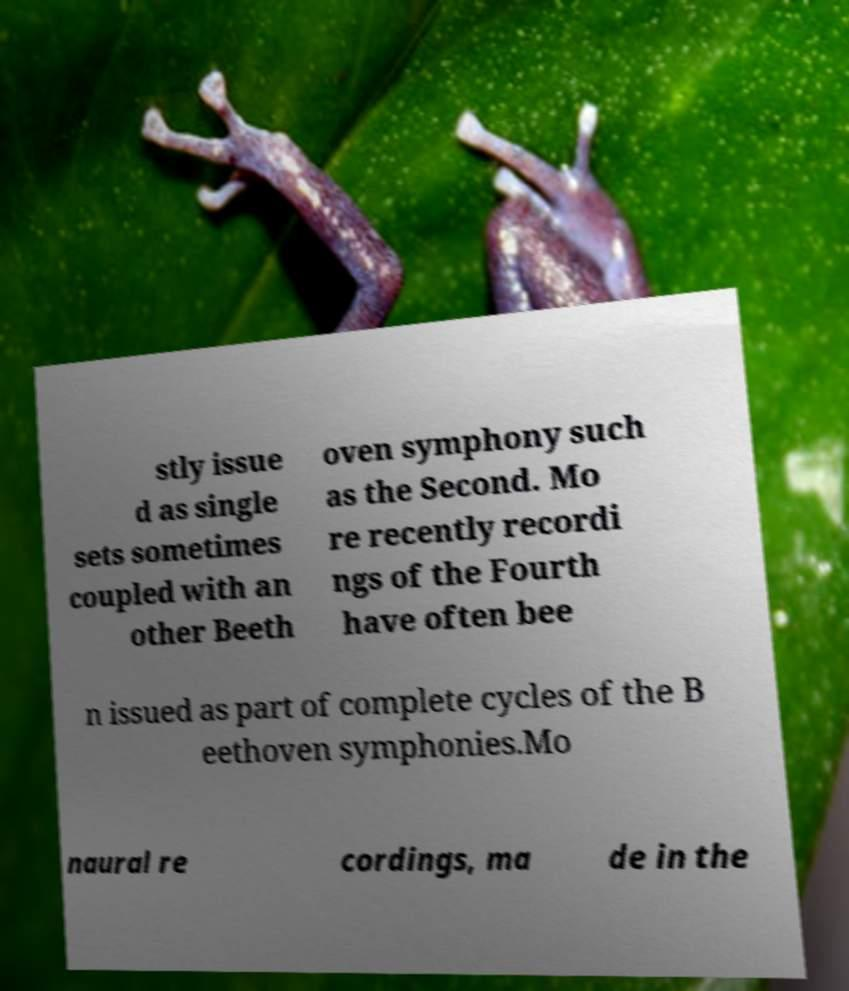Please identify and transcribe the text found in this image. stly issue d as single sets sometimes coupled with an other Beeth oven symphony such as the Second. Mo re recently recordi ngs of the Fourth have often bee n issued as part of complete cycles of the B eethoven symphonies.Mo naural re cordings, ma de in the 